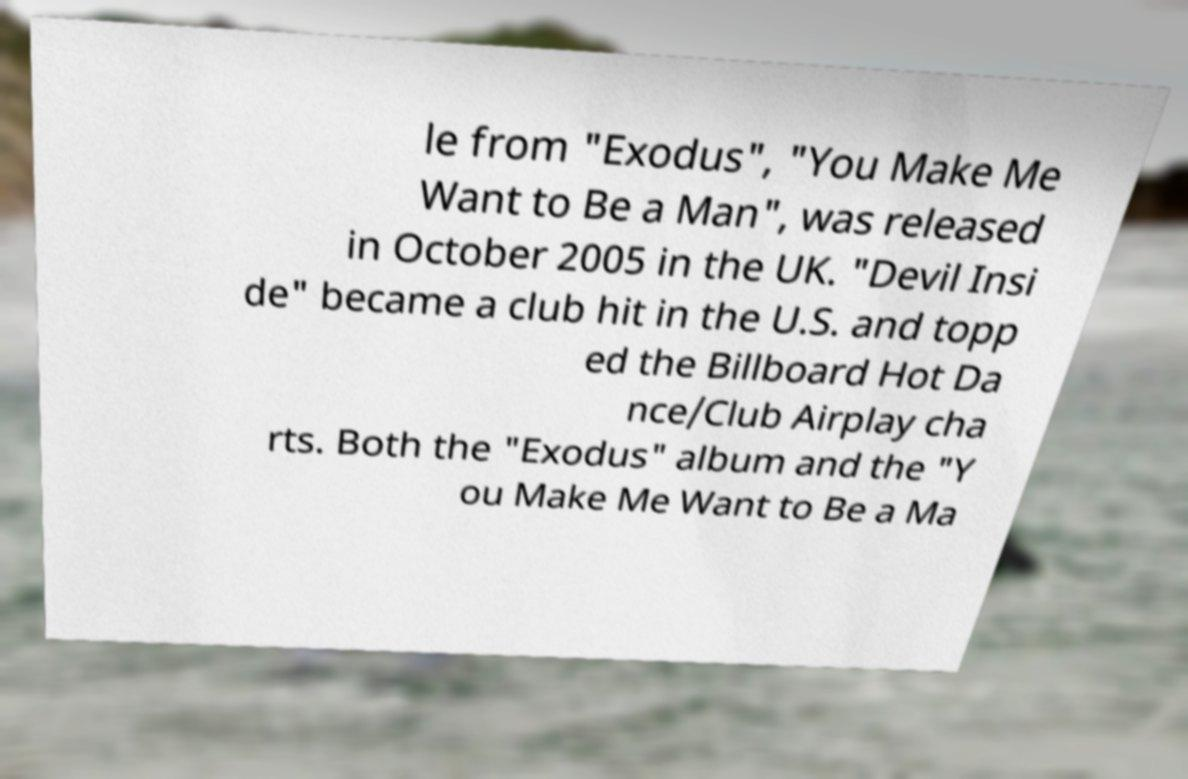Please identify and transcribe the text found in this image. le from "Exodus", "You Make Me Want to Be a Man", was released in October 2005 in the UK. "Devil Insi de" became a club hit in the U.S. and topp ed the Billboard Hot Da nce/Club Airplay cha rts. Both the "Exodus" album and the "Y ou Make Me Want to Be a Ma 